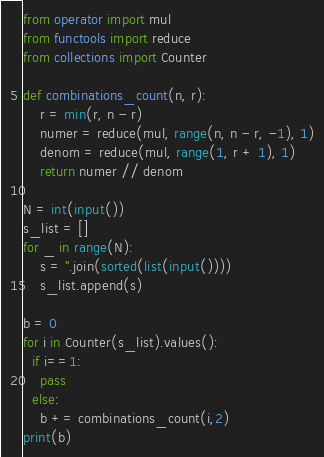<code> <loc_0><loc_0><loc_500><loc_500><_Python_>from operator import mul
from functools import reduce
from collections import Counter

def combinations_count(n, r):
    r = min(r, n - r)
    numer = reduce(mul, range(n, n - r, -1), 1)
    denom = reduce(mul, range(1, r + 1), 1)
    return numer // denom

N = int(input())
s_list = []
for _ in range(N):
    s = ''.join(sorted(list(input())))
    s_list.append(s)

b = 0
for i in Counter(s_list).values():
  if i==1:
    pass
  else:
    b += combinations_count(i,2)
print(b)</code> 